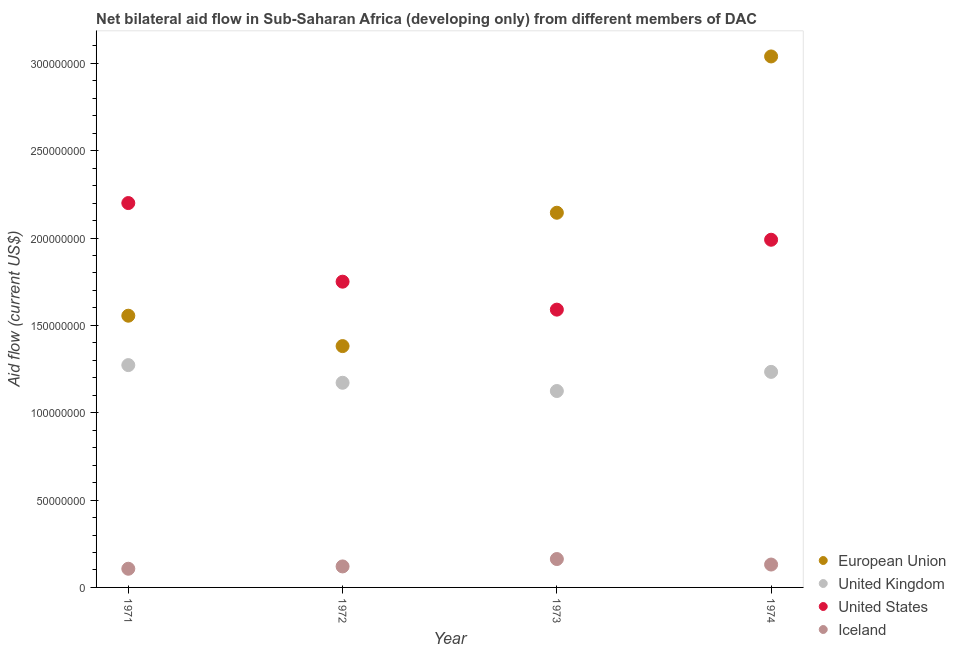Is the number of dotlines equal to the number of legend labels?
Give a very brief answer. Yes. What is the amount of aid given by iceland in 1971?
Your response must be concise. 1.07e+07. Across all years, what is the maximum amount of aid given by uk?
Ensure brevity in your answer.  1.27e+08. Across all years, what is the minimum amount of aid given by iceland?
Offer a terse response. 1.07e+07. In which year was the amount of aid given by eu minimum?
Ensure brevity in your answer.  1972. What is the total amount of aid given by uk in the graph?
Offer a very short reply. 4.80e+08. What is the difference between the amount of aid given by eu in 1971 and that in 1973?
Offer a very short reply. -5.89e+07. What is the difference between the amount of aid given by uk in 1974 and the amount of aid given by iceland in 1971?
Provide a succinct answer. 1.13e+08. What is the average amount of aid given by eu per year?
Provide a short and direct response. 2.03e+08. In the year 1972, what is the difference between the amount of aid given by us and amount of aid given by iceland?
Your answer should be very brief. 1.63e+08. In how many years, is the amount of aid given by iceland greater than 220000000 US$?
Your answer should be compact. 0. What is the ratio of the amount of aid given by uk in 1971 to that in 1973?
Offer a very short reply. 1.13. Is the amount of aid given by us in 1971 less than that in 1974?
Offer a very short reply. No. What is the difference between the highest and the second highest amount of aid given by uk?
Offer a terse response. 3.88e+06. What is the difference between the highest and the lowest amount of aid given by eu?
Your answer should be compact. 1.66e+08. Is the sum of the amount of aid given by uk in 1971 and 1974 greater than the maximum amount of aid given by us across all years?
Offer a very short reply. Yes. Is it the case that in every year, the sum of the amount of aid given by uk and amount of aid given by eu is greater than the sum of amount of aid given by us and amount of aid given by iceland?
Provide a short and direct response. Yes. Does the amount of aid given by iceland monotonically increase over the years?
Provide a succinct answer. No. Is the amount of aid given by iceland strictly less than the amount of aid given by us over the years?
Offer a very short reply. Yes. How many dotlines are there?
Keep it short and to the point. 4. How many years are there in the graph?
Your response must be concise. 4. Are the values on the major ticks of Y-axis written in scientific E-notation?
Keep it short and to the point. No. Does the graph contain any zero values?
Give a very brief answer. No. How many legend labels are there?
Provide a succinct answer. 4. How are the legend labels stacked?
Keep it short and to the point. Vertical. What is the title of the graph?
Give a very brief answer. Net bilateral aid flow in Sub-Saharan Africa (developing only) from different members of DAC. Does "Portugal" appear as one of the legend labels in the graph?
Provide a succinct answer. No. What is the label or title of the X-axis?
Offer a terse response. Year. What is the Aid flow (current US$) in European Union in 1971?
Provide a succinct answer. 1.56e+08. What is the Aid flow (current US$) in United Kingdom in 1971?
Make the answer very short. 1.27e+08. What is the Aid flow (current US$) of United States in 1971?
Your response must be concise. 2.20e+08. What is the Aid flow (current US$) of Iceland in 1971?
Ensure brevity in your answer.  1.07e+07. What is the Aid flow (current US$) in European Union in 1972?
Make the answer very short. 1.38e+08. What is the Aid flow (current US$) in United Kingdom in 1972?
Keep it short and to the point. 1.17e+08. What is the Aid flow (current US$) in United States in 1972?
Offer a very short reply. 1.75e+08. What is the Aid flow (current US$) of Iceland in 1972?
Offer a very short reply. 1.20e+07. What is the Aid flow (current US$) of European Union in 1973?
Offer a very short reply. 2.14e+08. What is the Aid flow (current US$) in United Kingdom in 1973?
Keep it short and to the point. 1.12e+08. What is the Aid flow (current US$) of United States in 1973?
Offer a terse response. 1.59e+08. What is the Aid flow (current US$) of Iceland in 1973?
Your response must be concise. 1.62e+07. What is the Aid flow (current US$) of European Union in 1974?
Your answer should be compact. 3.04e+08. What is the Aid flow (current US$) in United Kingdom in 1974?
Provide a short and direct response. 1.23e+08. What is the Aid flow (current US$) of United States in 1974?
Offer a terse response. 1.99e+08. What is the Aid flow (current US$) of Iceland in 1974?
Ensure brevity in your answer.  1.31e+07. Across all years, what is the maximum Aid flow (current US$) in European Union?
Offer a terse response. 3.04e+08. Across all years, what is the maximum Aid flow (current US$) of United Kingdom?
Make the answer very short. 1.27e+08. Across all years, what is the maximum Aid flow (current US$) in United States?
Ensure brevity in your answer.  2.20e+08. Across all years, what is the maximum Aid flow (current US$) of Iceland?
Ensure brevity in your answer.  1.62e+07. Across all years, what is the minimum Aid flow (current US$) of European Union?
Your answer should be very brief. 1.38e+08. Across all years, what is the minimum Aid flow (current US$) of United Kingdom?
Your answer should be very brief. 1.12e+08. Across all years, what is the minimum Aid flow (current US$) of United States?
Provide a succinct answer. 1.59e+08. Across all years, what is the minimum Aid flow (current US$) in Iceland?
Give a very brief answer. 1.07e+07. What is the total Aid flow (current US$) of European Union in the graph?
Make the answer very short. 8.12e+08. What is the total Aid flow (current US$) of United Kingdom in the graph?
Keep it short and to the point. 4.80e+08. What is the total Aid flow (current US$) of United States in the graph?
Your response must be concise. 7.53e+08. What is the total Aid flow (current US$) in Iceland in the graph?
Offer a very short reply. 5.21e+07. What is the difference between the Aid flow (current US$) of European Union in 1971 and that in 1972?
Your response must be concise. 1.74e+07. What is the difference between the Aid flow (current US$) in United Kingdom in 1971 and that in 1972?
Offer a terse response. 1.01e+07. What is the difference between the Aid flow (current US$) in United States in 1971 and that in 1972?
Your response must be concise. 4.50e+07. What is the difference between the Aid flow (current US$) in Iceland in 1971 and that in 1972?
Provide a short and direct response. -1.33e+06. What is the difference between the Aid flow (current US$) of European Union in 1971 and that in 1973?
Offer a terse response. -5.89e+07. What is the difference between the Aid flow (current US$) in United Kingdom in 1971 and that in 1973?
Your answer should be very brief. 1.48e+07. What is the difference between the Aid flow (current US$) in United States in 1971 and that in 1973?
Offer a very short reply. 6.10e+07. What is the difference between the Aid flow (current US$) in Iceland in 1971 and that in 1973?
Your response must be concise. -5.56e+06. What is the difference between the Aid flow (current US$) of European Union in 1971 and that in 1974?
Ensure brevity in your answer.  -1.48e+08. What is the difference between the Aid flow (current US$) in United Kingdom in 1971 and that in 1974?
Your answer should be compact. 3.88e+06. What is the difference between the Aid flow (current US$) in United States in 1971 and that in 1974?
Your answer should be compact. 2.10e+07. What is the difference between the Aid flow (current US$) of Iceland in 1971 and that in 1974?
Make the answer very short. -2.41e+06. What is the difference between the Aid flow (current US$) in European Union in 1972 and that in 1973?
Keep it short and to the point. -7.63e+07. What is the difference between the Aid flow (current US$) of United Kingdom in 1972 and that in 1973?
Ensure brevity in your answer.  4.72e+06. What is the difference between the Aid flow (current US$) of United States in 1972 and that in 1973?
Offer a very short reply. 1.60e+07. What is the difference between the Aid flow (current US$) in Iceland in 1972 and that in 1973?
Your answer should be compact. -4.23e+06. What is the difference between the Aid flow (current US$) of European Union in 1972 and that in 1974?
Your answer should be compact. -1.66e+08. What is the difference between the Aid flow (current US$) in United Kingdom in 1972 and that in 1974?
Ensure brevity in your answer.  -6.23e+06. What is the difference between the Aid flow (current US$) in United States in 1972 and that in 1974?
Give a very brief answer. -2.40e+07. What is the difference between the Aid flow (current US$) in Iceland in 1972 and that in 1974?
Your answer should be very brief. -1.08e+06. What is the difference between the Aid flow (current US$) of European Union in 1973 and that in 1974?
Offer a very short reply. -8.95e+07. What is the difference between the Aid flow (current US$) in United Kingdom in 1973 and that in 1974?
Keep it short and to the point. -1.10e+07. What is the difference between the Aid flow (current US$) in United States in 1973 and that in 1974?
Keep it short and to the point. -4.00e+07. What is the difference between the Aid flow (current US$) in Iceland in 1973 and that in 1974?
Offer a terse response. 3.15e+06. What is the difference between the Aid flow (current US$) of European Union in 1971 and the Aid flow (current US$) of United Kingdom in 1972?
Ensure brevity in your answer.  3.84e+07. What is the difference between the Aid flow (current US$) in European Union in 1971 and the Aid flow (current US$) in United States in 1972?
Offer a very short reply. -1.95e+07. What is the difference between the Aid flow (current US$) in European Union in 1971 and the Aid flow (current US$) in Iceland in 1972?
Your response must be concise. 1.44e+08. What is the difference between the Aid flow (current US$) in United Kingdom in 1971 and the Aid flow (current US$) in United States in 1972?
Your answer should be compact. -4.78e+07. What is the difference between the Aid flow (current US$) in United Kingdom in 1971 and the Aid flow (current US$) in Iceland in 1972?
Ensure brevity in your answer.  1.15e+08. What is the difference between the Aid flow (current US$) of United States in 1971 and the Aid flow (current US$) of Iceland in 1972?
Offer a very short reply. 2.08e+08. What is the difference between the Aid flow (current US$) in European Union in 1971 and the Aid flow (current US$) in United Kingdom in 1973?
Make the answer very short. 4.31e+07. What is the difference between the Aid flow (current US$) of European Union in 1971 and the Aid flow (current US$) of United States in 1973?
Offer a very short reply. -3.48e+06. What is the difference between the Aid flow (current US$) of European Union in 1971 and the Aid flow (current US$) of Iceland in 1973?
Provide a succinct answer. 1.39e+08. What is the difference between the Aid flow (current US$) of United Kingdom in 1971 and the Aid flow (current US$) of United States in 1973?
Provide a short and direct response. -3.18e+07. What is the difference between the Aid flow (current US$) of United Kingdom in 1971 and the Aid flow (current US$) of Iceland in 1973?
Give a very brief answer. 1.11e+08. What is the difference between the Aid flow (current US$) in United States in 1971 and the Aid flow (current US$) in Iceland in 1973?
Your answer should be compact. 2.04e+08. What is the difference between the Aid flow (current US$) in European Union in 1971 and the Aid flow (current US$) in United Kingdom in 1974?
Ensure brevity in your answer.  3.22e+07. What is the difference between the Aid flow (current US$) in European Union in 1971 and the Aid flow (current US$) in United States in 1974?
Your answer should be compact. -4.35e+07. What is the difference between the Aid flow (current US$) of European Union in 1971 and the Aid flow (current US$) of Iceland in 1974?
Your answer should be compact. 1.42e+08. What is the difference between the Aid flow (current US$) in United Kingdom in 1971 and the Aid flow (current US$) in United States in 1974?
Provide a short and direct response. -7.18e+07. What is the difference between the Aid flow (current US$) of United Kingdom in 1971 and the Aid flow (current US$) of Iceland in 1974?
Make the answer very short. 1.14e+08. What is the difference between the Aid flow (current US$) in United States in 1971 and the Aid flow (current US$) in Iceland in 1974?
Give a very brief answer. 2.07e+08. What is the difference between the Aid flow (current US$) of European Union in 1972 and the Aid flow (current US$) of United Kingdom in 1973?
Make the answer very short. 2.57e+07. What is the difference between the Aid flow (current US$) in European Union in 1972 and the Aid flow (current US$) in United States in 1973?
Your response must be concise. -2.09e+07. What is the difference between the Aid flow (current US$) of European Union in 1972 and the Aid flow (current US$) of Iceland in 1973?
Your answer should be compact. 1.22e+08. What is the difference between the Aid flow (current US$) of United Kingdom in 1972 and the Aid flow (current US$) of United States in 1973?
Your answer should be very brief. -4.19e+07. What is the difference between the Aid flow (current US$) in United Kingdom in 1972 and the Aid flow (current US$) in Iceland in 1973?
Provide a succinct answer. 1.01e+08. What is the difference between the Aid flow (current US$) in United States in 1972 and the Aid flow (current US$) in Iceland in 1973?
Offer a terse response. 1.59e+08. What is the difference between the Aid flow (current US$) of European Union in 1972 and the Aid flow (current US$) of United Kingdom in 1974?
Provide a short and direct response. 1.48e+07. What is the difference between the Aid flow (current US$) of European Union in 1972 and the Aid flow (current US$) of United States in 1974?
Provide a short and direct response. -6.09e+07. What is the difference between the Aid flow (current US$) in European Union in 1972 and the Aid flow (current US$) in Iceland in 1974?
Offer a terse response. 1.25e+08. What is the difference between the Aid flow (current US$) of United Kingdom in 1972 and the Aid flow (current US$) of United States in 1974?
Make the answer very short. -8.19e+07. What is the difference between the Aid flow (current US$) in United Kingdom in 1972 and the Aid flow (current US$) in Iceland in 1974?
Make the answer very short. 1.04e+08. What is the difference between the Aid flow (current US$) of United States in 1972 and the Aid flow (current US$) of Iceland in 1974?
Your answer should be compact. 1.62e+08. What is the difference between the Aid flow (current US$) in European Union in 1973 and the Aid flow (current US$) in United Kingdom in 1974?
Ensure brevity in your answer.  9.11e+07. What is the difference between the Aid flow (current US$) of European Union in 1973 and the Aid flow (current US$) of United States in 1974?
Your response must be concise. 1.55e+07. What is the difference between the Aid flow (current US$) of European Union in 1973 and the Aid flow (current US$) of Iceland in 1974?
Your answer should be compact. 2.01e+08. What is the difference between the Aid flow (current US$) in United Kingdom in 1973 and the Aid flow (current US$) in United States in 1974?
Your response must be concise. -8.66e+07. What is the difference between the Aid flow (current US$) in United Kingdom in 1973 and the Aid flow (current US$) in Iceland in 1974?
Offer a very short reply. 9.93e+07. What is the difference between the Aid flow (current US$) in United States in 1973 and the Aid flow (current US$) in Iceland in 1974?
Keep it short and to the point. 1.46e+08. What is the average Aid flow (current US$) of European Union per year?
Offer a very short reply. 2.03e+08. What is the average Aid flow (current US$) of United Kingdom per year?
Your answer should be compact. 1.20e+08. What is the average Aid flow (current US$) of United States per year?
Your answer should be compact. 1.88e+08. What is the average Aid flow (current US$) of Iceland per year?
Your response must be concise. 1.30e+07. In the year 1971, what is the difference between the Aid flow (current US$) of European Union and Aid flow (current US$) of United Kingdom?
Provide a short and direct response. 2.83e+07. In the year 1971, what is the difference between the Aid flow (current US$) of European Union and Aid flow (current US$) of United States?
Provide a short and direct response. -6.45e+07. In the year 1971, what is the difference between the Aid flow (current US$) of European Union and Aid flow (current US$) of Iceland?
Your answer should be very brief. 1.45e+08. In the year 1971, what is the difference between the Aid flow (current US$) in United Kingdom and Aid flow (current US$) in United States?
Your answer should be compact. -9.28e+07. In the year 1971, what is the difference between the Aid flow (current US$) in United Kingdom and Aid flow (current US$) in Iceland?
Keep it short and to the point. 1.17e+08. In the year 1971, what is the difference between the Aid flow (current US$) in United States and Aid flow (current US$) in Iceland?
Your answer should be very brief. 2.09e+08. In the year 1972, what is the difference between the Aid flow (current US$) in European Union and Aid flow (current US$) in United Kingdom?
Your response must be concise. 2.10e+07. In the year 1972, what is the difference between the Aid flow (current US$) of European Union and Aid flow (current US$) of United States?
Provide a succinct answer. -3.69e+07. In the year 1972, what is the difference between the Aid flow (current US$) in European Union and Aid flow (current US$) in Iceland?
Make the answer very short. 1.26e+08. In the year 1972, what is the difference between the Aid flow (current US$) in United Kingdom and Aid flow (current US$) in United States?
Your answer should be very brief. -5.79e+07. In the year 1972, what is the difference between the Aid flow (current US$) in United Kingdom and Aid flow (current US$) in Iceland?
Your answer should be very brief. 1.05e+08. In the year 1972, what is the difference between the Aid flow (current US$) in United States and Aid flow (current US$) in Iceland?
Keep it short and to the point. 1.63e+08. In the year 1973, what is the difference between the Aid flow (current US$) in European Union and Aid flow (current US$) in United Kingdom?
Give a very brief answer. 1.02e+08. In the year 1973, what is the difference between the Aid flow (current US$) in European Union and Aid flow (current US$) in United States?
Your answer should be very brief. 5.55e+07. In the year 1973, what is the difference between the Aid flow (current US$) in European Union and Aid flow (current US$) in Iceland?
Your answer should be very brief. 1.98e+08. In the year 1973, what is the difference between the Aid flow (current US$) in United Kingdom and Aid flow (current US$) in United States?
Offer a terse response. -4.66e+07. In the year 1973, what is the difference between the Aid flow (current US$) in United Kingdom and Aid flow (current US$) in Iceland?
Your answer should be very brief. 9.62e+07. In the year 1973, what is the difference between the Aid flow (current US$) of United States and Aid flow (current US$) of Iceland?
Your answer should be compact. 1.43e+08. In the year 1974, what is the difference between the Aid flow (current US$) in European Union and Aid flow (current US$) in United Kingdom?
Provide a succinct answer. 1.81e+08. In the year 1974, what is the difference between the Aid flow (current US$) of European Union and Aid flow (current US$) of United States?
Your answer should be compact. 1.05e+08. In the year 1974, what is the difference between the Aid flow (current US$) in European Union and Aid flow (current US$) in Iceland?
Your response must be concise. 2.91e+08. In the year 1974, what is the difference between the Aid flow (current US$) of United Kingdom and Aid flow (current US$) of United States?
Your answer should be compact. -7.56e+07. In the year 1974, what is the difference between the Aid flow (current US$) of United Kingdom and Aid flow (current US$) of Iceland?
Provide a succinct answer. 1.10e+08. In the year 1974, what is the difference between the Aid flow (current US$) in United States and Aid flow (current US$) in Iceland?
Give a very brief answer. 1.86e+08. What is the ratio of the Aid flow (current US$) of European Union in 1971 to that in 1972?
Ensure brevity in your answer.  1.13. What is the ratio of the Aid flow (current US$) in United Kingdom in 1971 to that in 1972?
Provide a short and direct response. 1.09. What is the ratio of the Aid flow (current US$) of United States in 1971 to that in 1972?
Your answer should be compact. 1.26. What is the ratio of the Aid flow (current US$) of Iceland in 1971 to that in 1972?
Your response must be concise. 0.89. What is the ratio of the Aid flow (current US$) of European Union in 1971 to that in 1973?
Provide a succinct answer. 0.73. What is the ratio of the Aid flow (current US$) in United Kingdom in 1971 to that in 1973?
Keep it short and to the point. 1.13. What is the ratio of the Aid flow (current US$) of United States in 1971 to that in 1973?
Your answer should be compact. 1.38. What is the ratio of the Aid flow (current US$) of Iceland in 1971 to that in 1973?
Offer a very short reply. 0.66. What is the ratio of the Aid flow (current US$) of European Union in 1971 to that in 1974?
Make the answer very short. 0.51. What is the ratio of the Aid flow (current US$) in United Kingdom in 1971 to that in 1974?
Offer a very short reply. 1.03. What is the ratio of the Aid flow (current US$) of United States in 1971 to that in 1974?
Provide a succinct answer. 1.11. What is the ratio of the Aid flow (current US$) of Iceland in 1971 to that in 1974?
Make the answer very short. 0.82. What is the ratio of the Aid flow (current US$) in European Union in 1972 to that in 1973?
Your answer should be compact. 0.64. What is the ratio of the Aid flow (current US$) of United Kingdom in 1972 to that in 1973?
Your answer should be very brief. 1.04. What is the ratio of the Aid flow (current US$) of United States in 1972 to that in 1973?
Offer a very short reply. 1.1. What is the ratio of the Aid flow (current US$) in Iceland in 1972 to that in 1973?
Offer a very short reply. 0.74. What is the ratio of the Aid flow (current US$) of European Union in 1972 to that in 1974?
Offer a terse response. 0.45. What is the ratio of the Aid flow (current US$) in United Kingdom in 1972 to that in 1974?
Offer a very short reply. 0.95. What is the ratio of the Aid flow (current US$) of United States in 1972 to that in 1974?
Keep it short and to the point. 0.88. What is the ratio of the Aid flow (current US$) in Iceland in 1972 to that in 1974?
Your answer should be compact. 0.92. What is the ratio of the Aid flow (current US$) of European Union in 1973 to that in 1974?
Provide a succinct answer. 0.71. What is the ratio of the Aid flow (current US$) in United Kingdom in 1973 to that in 1974?
Provide a succinct answer. 0.91. What is the ratio of the Aid flow (current US$) in United States in 1973 to that in 1974?
Your response must be concise. 0.8. What is the ratio of the Aid flow (current US$) of Iceland in 1973 to that in 1974?
Offer a very short reply. 1.24. What is the difference between the highest and the second highest Aid flow (current US$) of European Union?
Offer a very short reply. 8.95e+07. What is the difference between the highest and the second highest Aid flow (current US$) in United Kingdom?
Make the answer very short. 3.88e+06. What is the difference between the highest and the second highest Aid flow (current US$) in United States?
Your response must be concise. 2.10e+07. What is the difference between the highest and the second highest Aid flow (current US$) of Iceland?
Offer a terse response. 3.15e+06. What is the difference between the highest and the lowest Aid flow (current US$) of European Union?
Ensure brevity in your answer.  1.66e+08. What is the difference between the highest and the lowest Aid flow (current US$) in United Kingdom?
Give a very brief answer. 1.48e+07. What is the difference between the highest and the lowest Aid flow (current US$) in United States?
Your answer should be compact. 6.10e+07. What is the difference between the highest and the lowest Aid flow (current US$) of Iceland?
Your answer should be compact. 5.56e+06. 